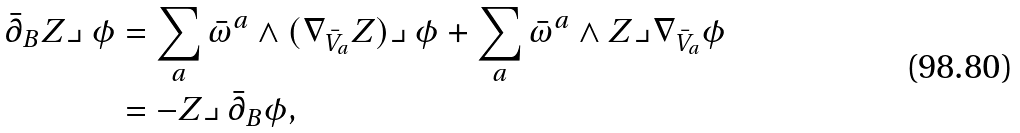Convert formula to latex. <formula><loc_0><loc_0><loc_500><loc_500>\bar { \partial } _ { B } Z \lrcorner \, \phi & = \sum _ { a } \bar { \omega } ^ { a } \wedge ( \nabla _ { \bar { V } _ { a } } Z ) \lrcorner \, \phi + \sum _ { a } \bar { \omega } ^ { a } \wedge Z \lrcorner \nabla _ { \bar { V } _ { a } } \phi \\ & = - Z \lrcorner \, \bar { \partial } _ { B } \phi ,</formula> 